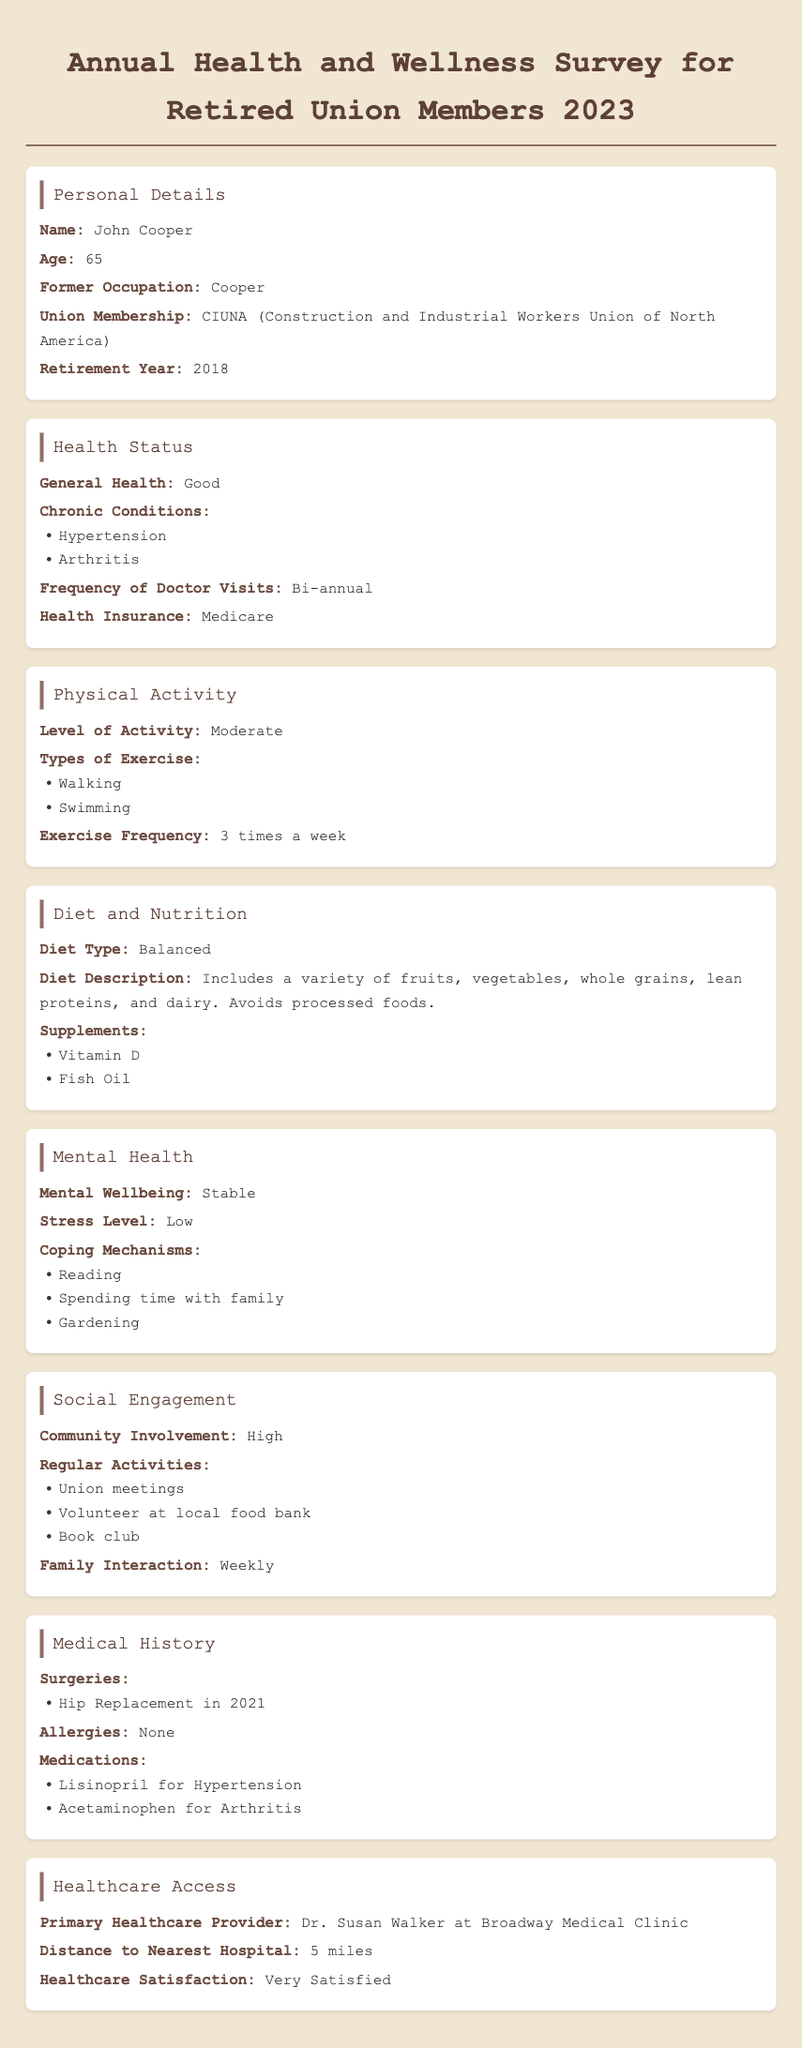What is the name of the individual surveyed? The document states that the individual's name is provided in the personal details section.
Answer: John Cooper What is the age of the person filling out the survey? The age is listed directly in the personal details section.
Answer: 65 What chronic conditions does the individual have? Chronic conditions are listed in the health status section, specifically mentioning the person's health issues.
Answer: Hypertension, Arthritis How often does the person visit the doctor? The frequency of doctor visits is mentioned in the health status section as a specific interval.
Answer: Bi-annual What type of diet does the individual follow? The diet type is specified in the diet and nutrition section.
Answer: Balanced How many times a week does the individual exercise? The exercise frequency is outlined in the physical activity section.
Answer: 3 times a week What is the individual's coping mechanism for stress? Coping mechanisms are listed under mental health, showing the person's strategies for dealing with stress.
Answer: Reading, Spending time with family, Gardening Who is the primary healthcare provider? The primary healthcare provider is mentioned in the healthcare access section, highlighting their name and practice.
Answer: Dr. Susan Walker at Broadway Medical Clinic What is the individual's satisfaction level with healthcare access? The satisfaction level is directly stated in the healthcare access section as a qualitative assessment.
Answer: Very Satisfied 